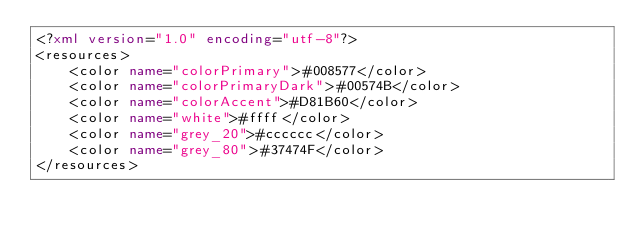<code> <loc_0><loc_0><loc_500><loc_500><_XML_><?xml version="1.0" encoding="utf-8"?>
<resources>
    <color name="colorPrimary">#008577</color>
    <color name="colorPrimaryDark">#00574B</color>
    <color name="colorAccent">#D81B60</color>
    <color name="white">#ffff</color>
    <color name="grey_20">#cccccc</color>
    <color name="grey_80">#37474F</color>
</resources>
</code> 